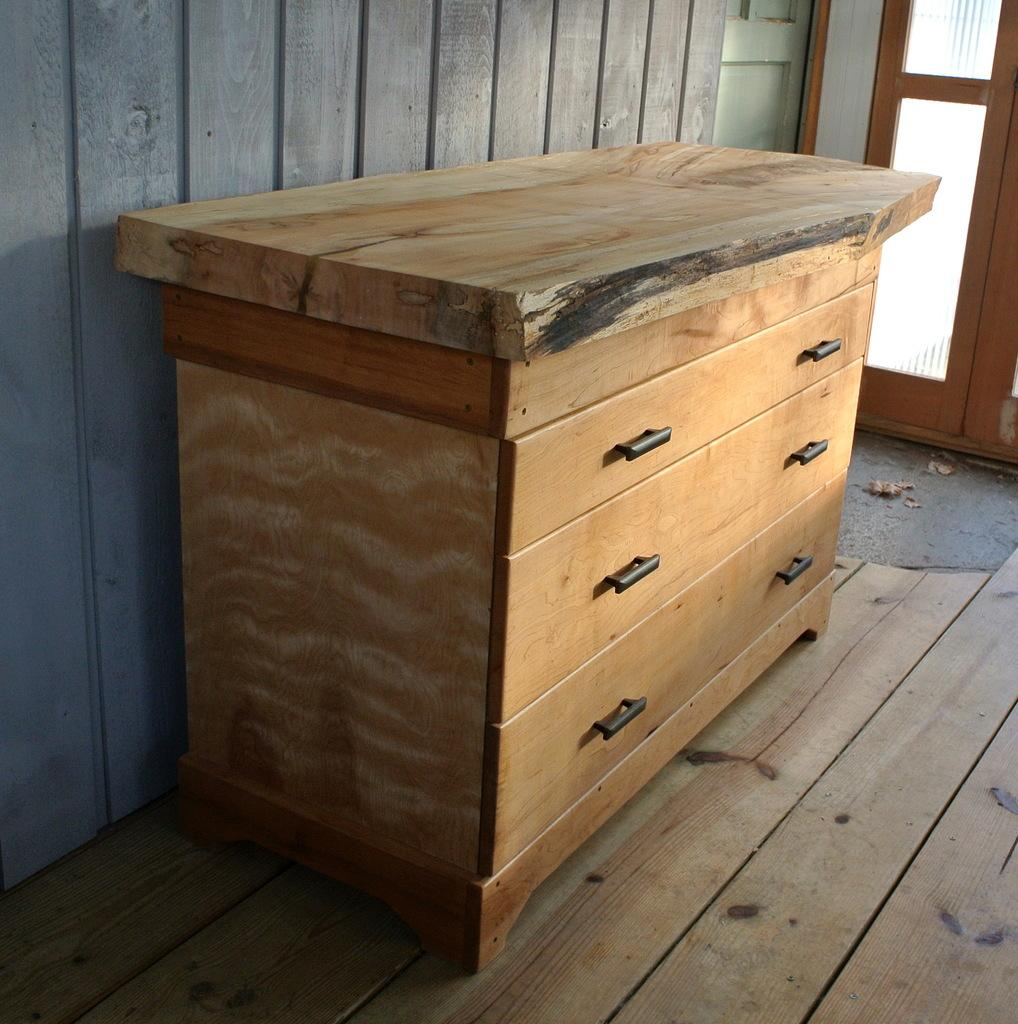What is the main setting of the image? The image is of a room. What is located in the middle of the room? There is a table in the middle of the room. Where is the door located in the room? The door is at the back of the room. How many women are holding a wrist in the image? There are no women or wrists present in the image. 